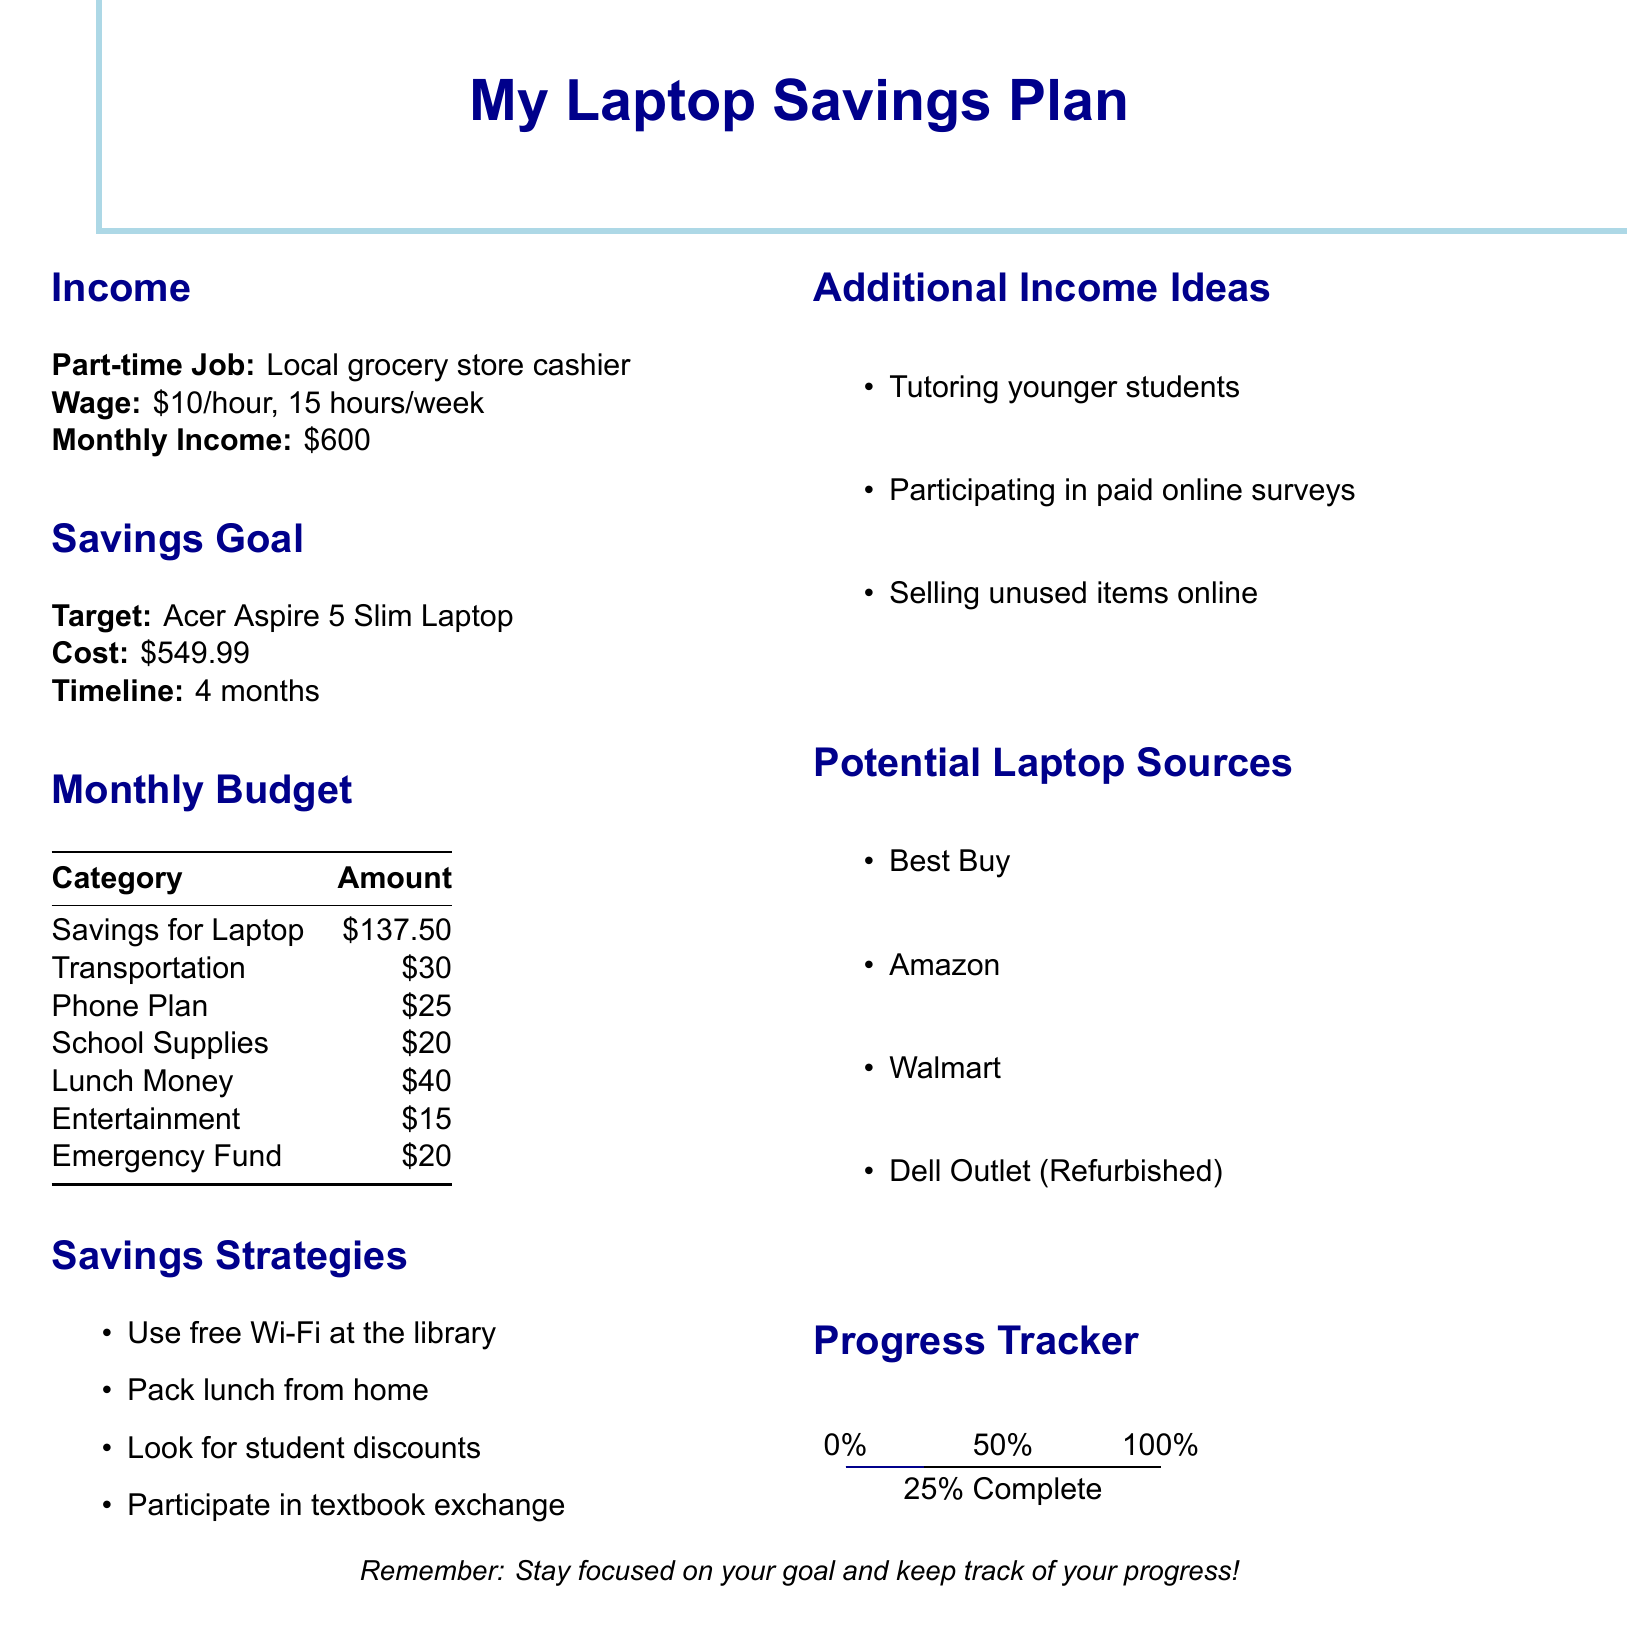What is the target savings goal? The target savings goal is the specific item or amount that the person aims to save for, here it is the Acer Aspire 5 Slim Laptop.
Answer: Acer Aspire 5 Slim Laptop What is the monthly income from the part-time job? The monthly income is calculated by the wage per hour multiplied by the hours worked per week and then multiplied by the number of weeks in a month. Here, it is $10/hour * 15 hours/week * 4 weeks = $600.
Answer: $600 How much money is allocated for entertainment? The amount allocated for entertainment is specified as part of the monthly budget.
Answer: $15 What is the cost of the laptop? The cost of the laptop is listed under the savings goal section, specifying how much needs to be saved.
Answer: $549.99 What percentage of the savings goal has been completed? The progress tracker indicates how much of the savings goal has been reached, stated as 25% complete.
Answer: 25% What is one of the suggested savings strategies? The document lists several strategies to save money. One of them is using free Wi-Fi at the library.
Answer: Use free Wi-Fi at the library Which store is mentioned as a potential source for the laptop? The document lists several sources where the laptop can be purchased, including Best Buy.
Answer: Best Buy What is the timeline to reach the savings goal? The timeline indicates how long it will take to reach the savings goal, which in this case is four months.
Answer: 4 months 